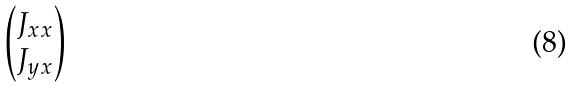<formula> <loc_0><loc_0><loc_500><loc_500>\begin{pmatrix} J _ { x x } \\ J _ { y x } \end{pmatrix}</formula> 